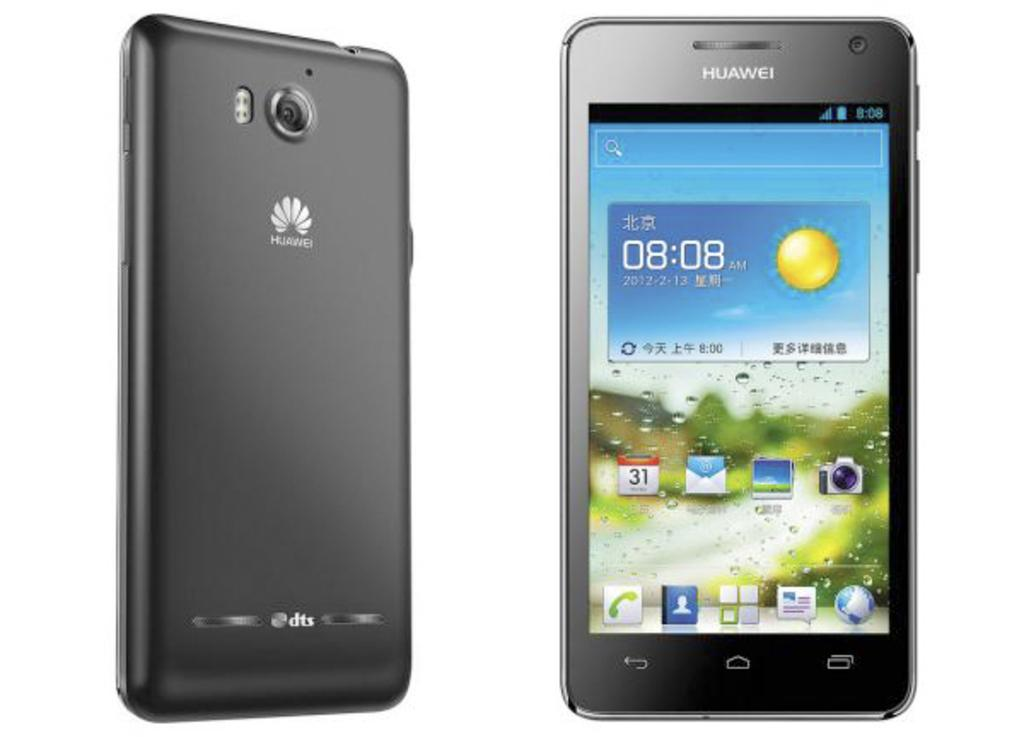<image>
Give a short and clear explanation of the subsequent image. A Huawei brand phone shows that the time is currently 08:08. 